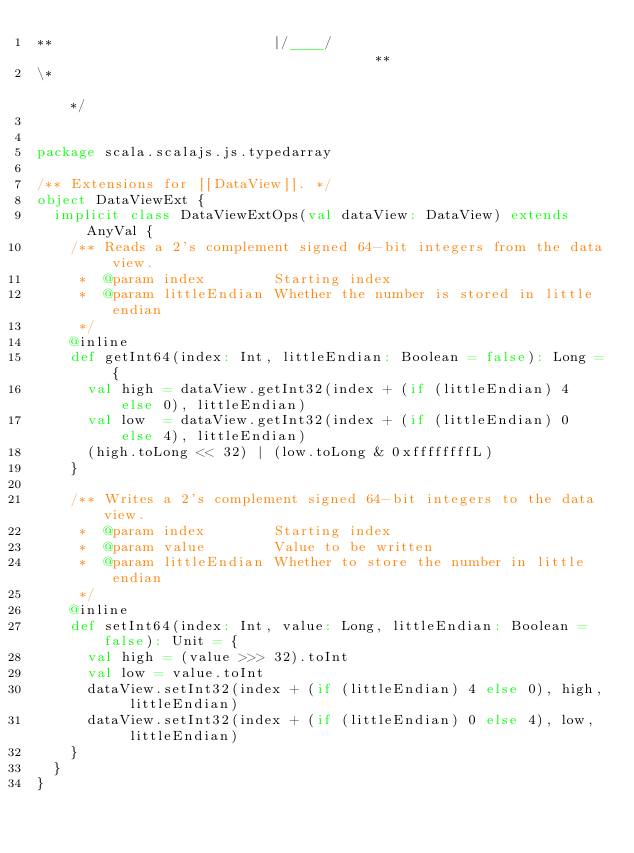<code> <loc_0><loc_0><loc_500><loc_500><_Scala_>**                          |/____/                                     **
\*                                                                      */


package scala.scalajs.js.typedarray

/** Extensions for [[DataView]]. */
object DataViewExt {
  implicit class DataViewExtOps(val dataView: DataView) extends AnyVal {
    /** Reads a 2's complement signed 64-bit integers from the data view.
     *  @param index        Starting index
     *  @param littleEndian Whether the number is stored in little endian
     */
    @inline
    def getInt64(index: Int, littleEndian: Boolean = false): Long = {
      val high = dataView.getInt32(index + (if (littleEndian) 4 else 0), littleEndian)
      val low  = dataView.getInt32(index + (if (littleEndian) 0 else 4), littleEndian)
      (high.toLong << 32) | (low.toLong & 0xffffffffL)
    }

    /** Writes a 2's complement signed 64-bit integers to the data view.
     *  @param index        Starting index
     *  @param value        Value to be written
     *  @param littleEndian Whether to store the number in little endian
     */
    @inline
    def setInt64(index: Int, value: Long, littleEndian: Boolean = false): Unit = {
      val high = (value >>> 32).toInt
      val low = value.toInt
      dataView.setInt32(index + (if (littleEndian) 4 else 0), high, littleEndian)
      dataView.setInt32(index + (if (littleEndian) 0 else 4), low,  littleEndian)
    }
  }
}
</code> 